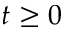Convert formula to latex. <formula><loc_0><loc_0><loc_500><loc_500>t \geq 0</formula> 